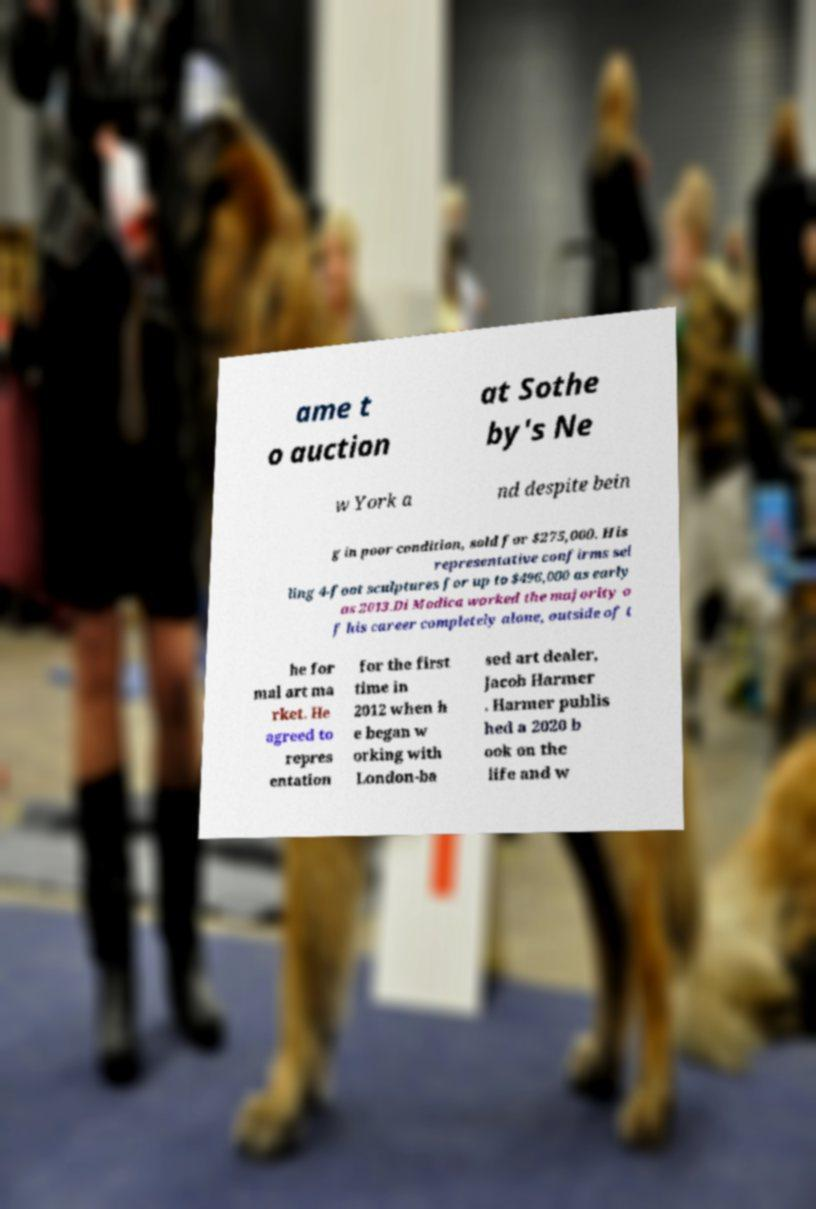Please read and relay the text visible in this image. What does it say? ame t o auction at Sothe by's Ne w York a nd despite bein g in poor condition, sold for $275,000. His representative confirms sel ling 4-foot sculptures for up to $496,000 as early as 2013.Di Modica worked the majority o f his career completely alone, outside of t he for mal art ma rket. He agreed to repres entation for the first time in 2012 when h e began w orking with London-ba sed art dealer, Jacob Harmer . Harmer publis hed a 2020 b ook on the life and w 